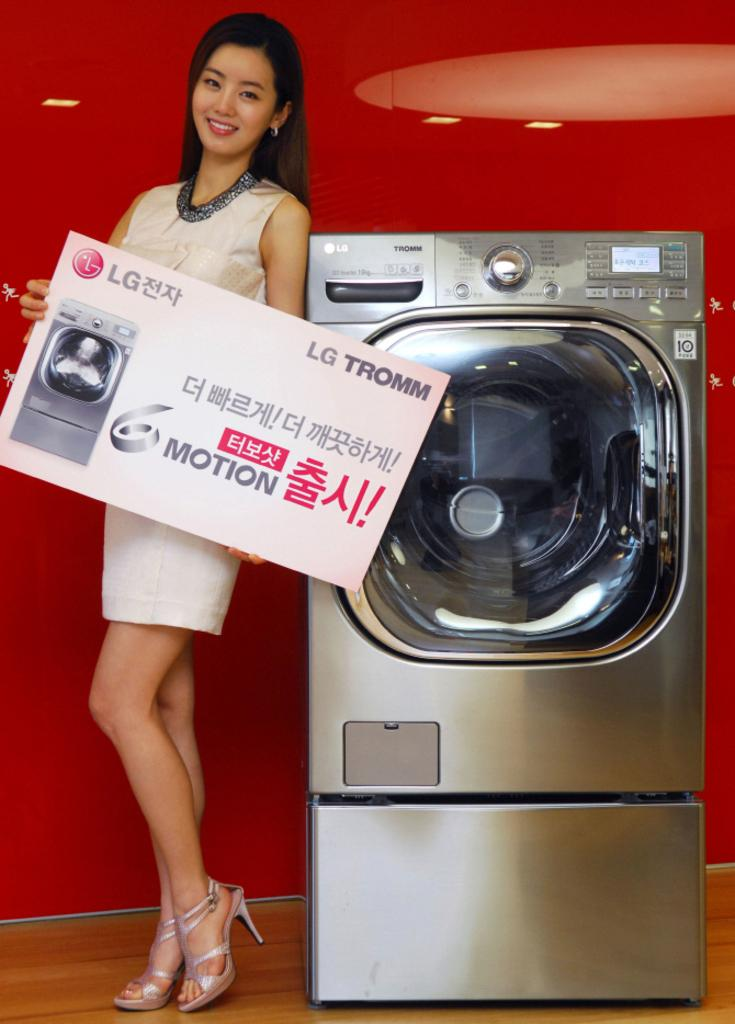Provide a one-sentence caption for the provided image. A picture of a LG Tromm washing machine. The background is red and there is a model on the picture holding a huge business card. 